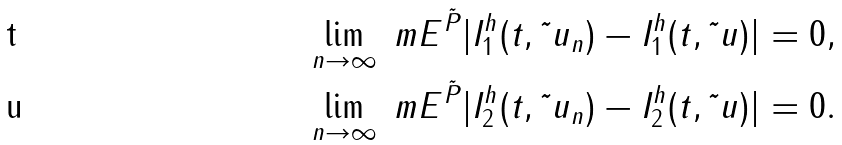Convert formula to latex. <formula><loc_0><loc_0><loc_500><loc_500>& \quad \lim _ { n \rightarrow \infty } \ m E ^ { \tilde { P } } | I ^ { h } _ { 1 } ( t , \tilde { \ } u _ { n } ) - I ^ { h } _ { 1 } ( t , \tilde { \ } u ) | = 0 , \\ & \quad \lim _ { n \rightarrow \infty } \ m E ^ { \tilde { P } } | I ^ { h } _ { 2 } ( t , \tilde { \ } u _ { n } ) - I ^ { h } _ { 2 } ( t , \tilde { \ } u ) | = 0 .</formula> 